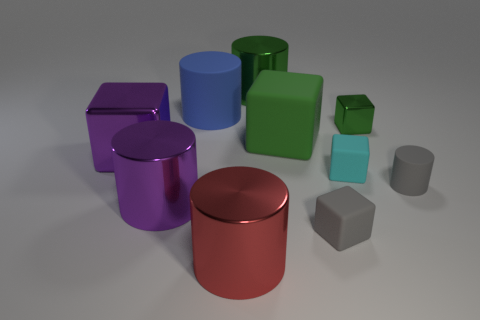Subtract 2 cubes. How many cubes are left? 3 Add 3 tiny cyan blocks. How many tiny cyan blocks are left? 4 Add 3 big cubes. How many big cubes exist? 5 Subtract 0 gray balls. How many objects are left? 10 Subtract all large purple objects. Subtract all big blue things. How many objects are left? 7 